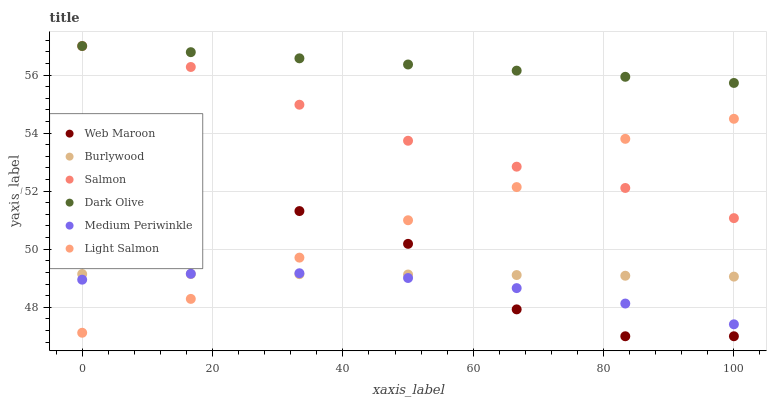Does Medium Periwinkle have the minimum area under the curve?
Answer yes or no. Yes. Does Dark Olive have the maximum area under the curve?
Answer yes or no. Yes. Does Burlywood have the minimum area under the curve?
Answer yes or no. No. Does Burlywood have the maximum area under the curve?
Answer yes or no. No. Is Dark Olive the smoothest?
Answer yes or no. Yes. Is Web Maroon the roughest?
Answer yes or no. Yes. Is Medium Periwinkle the smoothest?
Answer yes or no. No. Is Medium Periwinkle the roughest?
Answer yes or no. No. Does Web Maroon have the lowest value?
Answer yes or no. Yes. Does Medium Periwinkle have the lowest value?
Answer yes or no. No. Does Salmon have the highest value?
Answer yes or no. Yes. Does Medium Periwinkle have the highest value?
Answer yes or no. No. Is Light Salmon less than Dark Olive?
Answer yes or no. Yes. Is Salmon greater than Medium Periwinkle?
Answer yes or no. Yes. Does Web Maroon intersect Light Salmon?
Answer yes or no. Yes. Is Web Maroon less than Light Salmon?
Answer yes or no. No. Is Web Maroon greater than Light Salmon?
Answer yes or no. No. Does Light Salmon intersect Dark Olive?
Answer yes or no. No. 